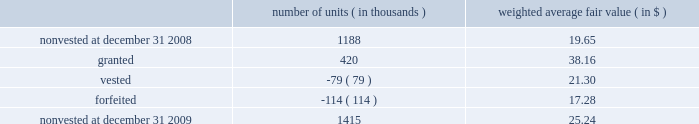During 2009 , the company extended the contractual life of 4 million fully vested share options held by 6 employees .
As a result of that modification , the company recognized additional compensation expense of $ 1 million for the year ended december 31 , 2009 .
Restricted stock units ( 201crsus 201d ) performance-based rsus .
The company grants performance-based rsus to the company 2019s executive officers and certain employees once per year .
The company may also grant performance-based rsus to certain new employees or to employees who assume positions of increasing responsibility at the time those events occur .
The number of performance-based rsus that ultimately vest is dependent on one or both of the following as per the terms of the specific award agreement : the achievement of 1 ) internal profitability targets ( performance condition ) and 2 ) market performance targets measured by the comparison of the company 2019s stock performance versus a defined peer group ( market condition ) .
The performance-based rsus generally cliff-vest during the company 2019s quarter-end september 30 black-out period three years from the date of grant .
The ultimate number of shares of the company 2019s series a common stock issued will range from zero to stretch , with stretch defined individually under each award , net of personal income taxes withheld .
The market condition is factored into the estimated fair value per unit and compensation expense for each award will be based on the probability of achieving internal profitability targets , as applicable , and recognized on a straight-line basis over the term of the respective grant , less estimated forfeitures .
For performance-based rsus granted without a performance condition , compensation expense is based on the fair value per unit recognized on a straight-line basis over the term of the grant , less estimated forfeitures .
In april 2007 , the company granted performance-based rsus to certain employees that vest annually in equal tranches beginning october 1 , 2008 through october 1 , 2011 and include a market condition .
The performance- based rsus awarded include a catch-up provision that provides for an additional year of vesting of previously unvested amounts , subject to certain maximums .
Compensation expense is based on the fair value per unit recognized on a straight-line basis over the term of the grant , less estimated forfeitures .
A summary of changes in performance-based rsus outstanding is as follows : number of weighted average fair value ( in thousands ) ( in $ ) .
The fair value of shares vested for performance-based rsus during the years ended december 31 , 2009 and 2008 was $ 2 million and $ 3 million , respectively .
There were no vestings that occurred during the year ended december 31 , 2007 .
Fair value for the company 2019s performance-based rsus was estimated at the grant date using a monte carlo simulation approach .
Monte carlo simulation was utilized to randomly generate future stock returns for the company and each company in the defined peer group for each grant based on company-specific dividend yields , volatilities and stock return correlations .
These returns were used to calculate future performance-based rsu vesting percentages and the simulated values of the vested performance-based rsus were then discounted to present value using a risk-free rate , yielding the expected value of these performance-based rsus .
%%transmsg*** transmitting job : d70731 pcn : 119000000 ***%%pcmsg|119 |00016|yes|no|02/10/2010 16:17|0|0|page is valid , no graphics -- color : n| .
What was the value of the nonvested shares at december 31 2009? 
Rationale: the value is the product of the number of shares by the price
Computations: (1415 * 25.24)
Answer: 35714.6. During 2009 , the company extended the contractual life of 4 million fully vested share options held by 6 employees .
As a result of that modification , the company recognized additional compensation expense of $ 1 million for the year ended december 31 , 2009 .
Restricted stock units ( 201crsus 201d ) performance-based rsus .
The company grants performance-based rsus to the company 2019s executive officers and certain employees once per year .
The company may also grant performance-based rsus to certain new employees or to employees who assume positions of increasing responsibility at the time those events occur .
The number of performance-based rsus that ultimately vest is dependent on one or both of the following as per the terms of the specific award agreement : the achievement of 1 ) internal profitability targets ( performance condition ) and 2 ) market performance targets measured by the comparison of the company 2019s stock performance versus a defined peer group ( market condition ) .
The performance-based rsus generally cliff-vest during the company 2019s quarter-end september 30 black-out period three years from the date of grant .
The ultimate number of shares of the company 2019s series a common stock issued will range from zero to stretch , with stretch defined individually under each award , net of personal income taxes withheld .
The market condition is factored into the estimated fair value per unit and compensation expense for each award will be based on the probability of achieving internal profitability targets , as applicable , and recognized on a straight-line basis over the term of the respective grant , less estimated forfeitures .
For performance-based rsus granted without a performance condition , compensation expense is based on the fair value per unit recognized on a straight-line basis over the term of the grant , less estimated forfeitures .
In april 2007 , the company granted performance-based rsus to certain employees that vest annually in equal tranches beginning october 1 , 2008 through october 1 , 2011 and include a market condition .
The performance- based rsus awarded include a catch-up provision that provides for an additional year of vesting of previously unvested amounts , subject to certain maximums .
Compensation expense is based on the fair value per unit recognized on a straight-line basis over the term of the grant , less estimated forfeitures .
A summary of changes in performance-based rsus outstanding is as follows : number of weighted average fair value ( in thousands ) ( in $ ) .
The fair value of shares vested for performance-based rsus during the years ended december 31 , 2009 and 2008 was $ 2 million and $ 3 million , respectively .
There were no vestings that occurred during the year ended december 31 , 2007 .
Fair value for the company 2019s performance-based rsus was estimated at the grant date using a monte carlo simulation approach .
Monte carlo simulation was utilized to randomly generate future stock returns for the company and each company in the defined peer group for each grant based on company-specific dividend yields , volatilities and stock return correlations .
These returns were used to calculate future performance-based rsu vesting percentages and the simulated values of the vested performance-based rsus were then discounted to present value using a risk-free rate , yielding the expected value of these performance-based rsus .
%%transmsg*** transmitting job : d70731 pcn : 119000000 ***%%pcmsg|119 |00016|yes|no|02/10/2010 16:17|0|0|page is valid , no graphics -- color : n| .
What was the net change number of units in 2009 in thousands? 
Rationale: the change is the summation of all activity both the increase and decrease
Computations: ((420 + -79) + -114)
Answer: 227.0. During 2009 , the company extended the contractual life of 4 million fully vested share options held by 6 employees .
As a result of that modification , the company recognized additional compensation expense of $ 1 million for the year ended december 31 , 2009 .
Restricted stock units ( 201crsus 201d ) performance-based rsus .
The company grants performance-based rsus to the company 2019s executive officers and certain employees once per year .
The company may also grant performance-based rsus to certain new employees or to employees who assume positions of increasing responsibility at the time those events occur .
The number of performance-based rsus that ultimately vest is dependent on one or both of the following as per the terms of the specific award agreement : the achievement of 1 ) internal profitability targets ( performance condition ) and 2 ) market performance targets measured by the comparison of the company 2019s stock performance versus a defined peer group ( market condition ) .
The performance-based rsus generally cliff-vest during the company 2019s quarter-end september 30 black-out period three years from the date of grant .
The ultimate number of shares of the company 2019s series a common stock issued will range from zero to stretch , with stretch defined individually under each award , net of personal income taxes withheld .
The market condition is factored into the estimated fair value per unit and compensation expense for each award will be based on the probability of achieving internal profitability targets , as applicable , and recognized on a straight-line basis over the term of the respective grant , less estimated forfeitures .
For performance-based rsus granted without a performance condition , compensation expense is based on the fair value per unit recognized on a straight-line basis over the term of the grant , less estimated forfeitures .
In april 2007 , the company granted performance-based rsus to certain employees that vest annually in equal tranches beginning october 1 , 2008 through october 1 , 2011 and include a market condition .
The performance- based rsus awarded include a catch-up provision that provides for an additional year of vesting of previously unvested amounts , subject to certain maximums .
Compensation expense is based on the fair value per unit recognized on a straight-line basis over the term of the grant , less estimated forfeitures .
A summary of changes in performance-based rsus outstanding is as follows : number of weighted average fair value ( in thousands ) ( in $ ) .
The fair value of shares vested for performance-based rsus during the years ended december 31 , 2009 and 2008 was $ 2 million and $ 3 million , respectively .
There were no vestings that occurred during the year ended december 31 , 2007 .
Fair value for the company 2019s performance-based rsus was estimated at the grant date using a monte carlo simulation approach .
Monte carlo simulation was utilized to randomly generate future stock returns for the company and each company in the defined peer group for each grant based on company-specific dividend yields , volatilities and stock return correlations .
These returns were used to calculate future performance-based rsu vesting percentages and the simulated values of the vested performance-based rsus were then discounted to present value using a risk-free rate , yielding the expected value of these performance-based rsus .
%%transmsg*** transmitting job : d70731 pcn : 119000000 ***%%pcmsg|119 |00016|yes|no|02/10/2010 16:17|0|0|page is valid , no graphics -- color : n| .
What is the net change in the balance of non vested units during 2009? 
Computations: (1415 - 1188)
Answer: 227.0. During 2009 , the company extended the contractual life of 4 million fully vested share options held by 6 employees .
As a result of that modification , the company recognized additional compensation expense of $ 1 million for the year ended december 31 , 2009 .
Restricted stock units ( 201crsus 201d ) performance-based rsus .
The company grants performance-based rsus to the company 2019s executive officers and certain employees once per year .
The company may also grant performance-based rsus to certain new employees or to employees who assume positions of increasing responsibility at the time those events occur .
The number of performance-based rsus that ultimately vest is dependent on one or both of the following as per the terms of the specific award agreement : the achievement of 1 ) internal profitability targets ( performance condition ) and 2 ) market performance targets measured by the comparison of the company 2019s stock performance versus a defined peer group ( market condition ) .
The performance-based rsus generally cliff-vest during the company 2019s quarter-end september 30 black-out period three years from the date of grant .
The ultimate number of shares of the company 2019s series a common stock issued will range from zero to stretch , with stretch defined individually under each award , net of personal income taxes withheld .
The market condition is factored into the estimated fair value per unit and compensation expense for each award will be based on the probability of achieving internal profitability targets , as applicable , and recognized on a straight-line basis over the term of the respective grant , less estimated forfeitures .
For performance-based rsus granted without a performance condition , compensation expense is based on the fair value per unit recognized on a straight-line basis over the term of the grant , less estimated forfeitures .
In april 2007 , the company granted performance-based rsus to certain employees that vest annually in equal tranches beginning october 1 , 2008 through october 1 , 2011 and include a market condition .
The performance- based rsus awarded include a catch-up provision that provides for an additional year of vesting of previously unvested amounts , subject to certain maximums .
Compensation expense is based on the fair value per unit recognized on a straight-line basis over the term of the grant , less estimated forfeitures .
A summary of changes in performance-based rsus outstanding is as follows : number of weighted average fair value ( in thousands ) ( in $ ) .
The fair value of shares vested for performance-based rsus during the years ended december 31 , 2009 and 2008 was $ 2 million and $ 3 million , respectively .
There were no vestings that occurred during the year ended december 31 , 2007 .
Fair value for the company 2019s performance-based rsus was estimated at the grant date using a monte carlo simulation approach .
Monte carlo simulation was utilized to randomly generate future stock returns for the company and each company in the defined peer group for each grant based on company-specific dividend yields , volatilities and stock return correlations .
These returns were used to calculate future performance-based rsu vesting percentages and the simulated values of the vested performance-based rsus were then discounted to present value using a risk-free rate , yielding the expected value of these performance-based rsus .
%%transmsg*** transmitting job : d70731 pcn : 119000000 ***%%pcmsg|119 |00016|yes|no|02/10/2010 16:17|0|0|page is valid , no graphics -- color : n| .
What is the total fair value of the non vested units as of december 31 , 2009 , ( in millions ) ? 
Computations: (((1415 * 1000) * 25.24) / 1000000)
Answer: 35.7146. 